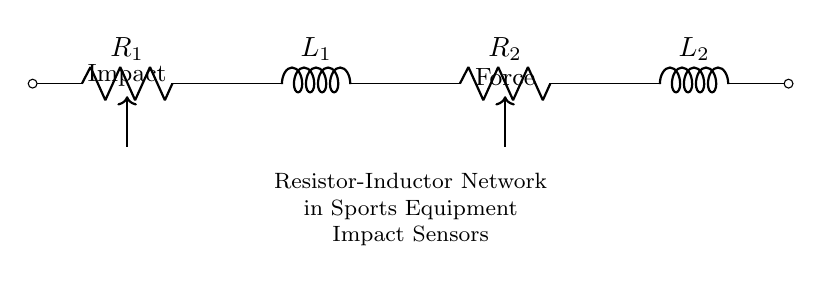What are the components in the circuit? The circuit consists of two resistors, R1 and R2, and two inductors, L1 and L2. This is evident from the diagram where each component is labeled accordingly.
Answer: R1, R2, L1, L2 What is the primary function of the resistors in this circuit? The resistors R1 and R2 in the circuit typically limit current and dissipate energy as heat. Their role is crucial in managing the overall resistance in the network.
Answer: Limit current What is the role of the inductors in the impact sensor circuit? The inductors L1 and L2 store energy in a magnetic field when current flows through them. They provide the circuit with the ability to oppose changes in current, which is important in dynamic conditions like impact forces.
Answer: Store energy Is the circuit series or parallel? The components are arranged in a series configuration since they are connected end to end, allowing the same current to flow through each component sequentially.
Answer: Series If the total resistance is needed, what would it be? The total resistance in a series circuit is simply the sum of the individual resistances, so it would be calculated as R1 + R2. The inductors do not contribute to resistance in this context.
Answer: R1 + R2 How does the impact force relate to the components in the circuit? The impact force affects the current flowing through the circuit. As the impact changes, it will alter the voltage drop across the resistors and the behavior of the inductors, impacting sensor readings.
Answer: Alters current 